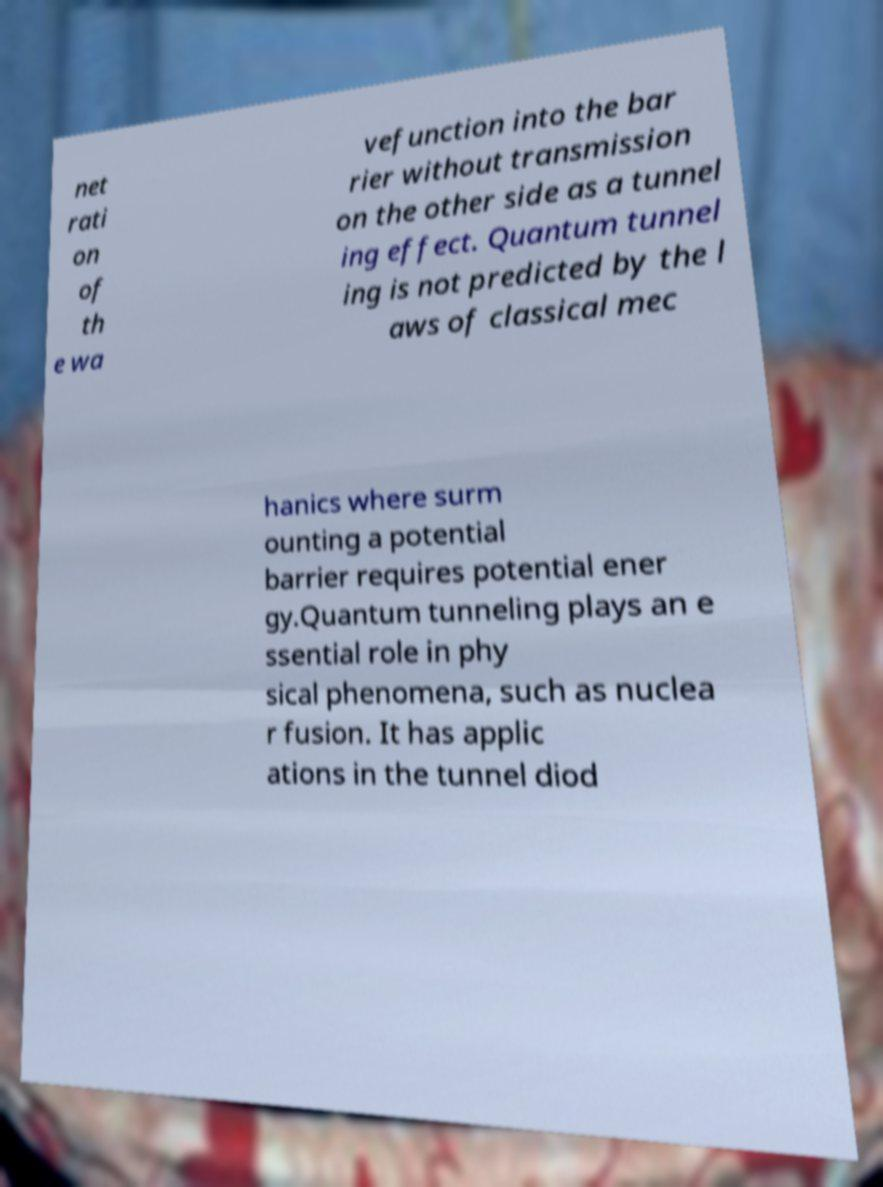Could you assist in decoding the text presented in this image and type it out clearly? net rati on of th e wa vefunction into the bar rier without transmission on the other side as a tunnel ing effect. Quantum tunnel ing is not predicted by the l aws of classical mec hanics where surm ounting a potential barrier requires potential ener gy.Quantum tunneling plays an e ssential role in phy sical phenomena, such as nuclea r fusion. It has applic ations in the tunnel diod 